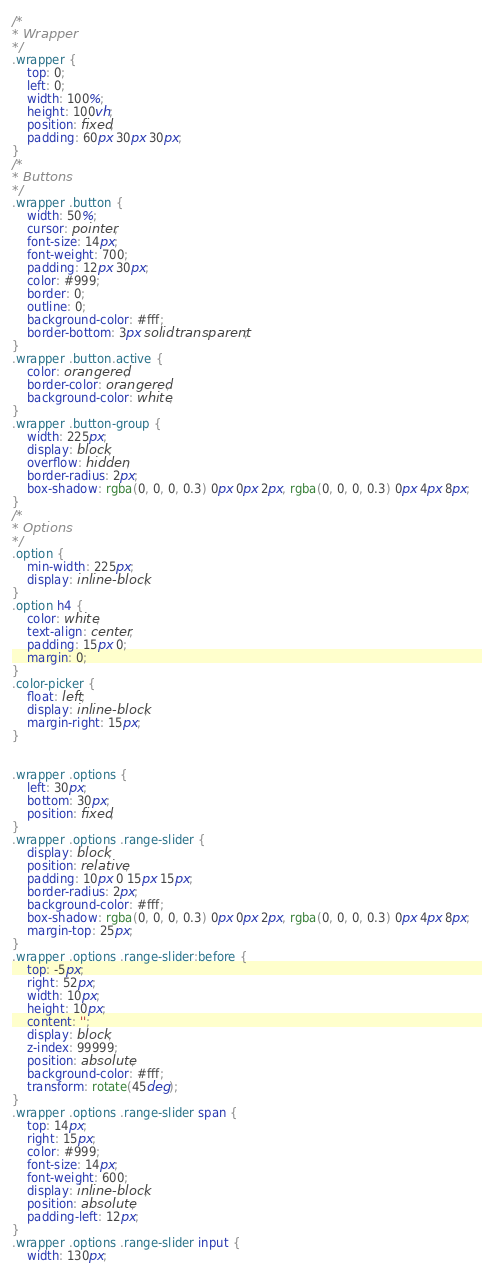Convert code to text. <code><loc_0><loc_0><loc_500><loc_500><_CSS_>/* 
* Wrapper
*/
.wrapper {
    top: 0;
    left: 0;
    width: 100%;
    height: 100vh;
    position: fixed;
    padding: 60px 30px 30px;
}
/* 
* Buttons
*/
.wrapper .button {
    width: 50%;
    cursor: pointer;
    font-size: 14px;
    font-weight: 700;
    padding: 12px 30px;
    color: #999;
    border: 0;
    outline: 0;
    background-color: #fff;
    border-bottom: 3px solid transparent;
}
.wrapper .button.active {
    color: orangered;
    border-color: orangered;
    background-color: white;
}
.wrapper .button-group {
    width: 225px;
    display: block;
    overflow: hidden;
    border-radius: 2px;
    box-shadow: rgba(0, 0, 0, 0.3) 0px 0px 2px, rgba(0, 0, 0, 0.3) 0px 4px 8px;
}
/* 
* Options
*/
.option {
    min-width: 225px;
    display: inline-block;
}
.option h4 {
    color: white;
    text-align: center;
    padding: 15px 0;
    margin: 0;
}
.color-picker {
    float: left;
    display: inline-block;
    margin-right: 15px;
}


.wrapper .options {
    left: 30px;
    bottom: 30px;
    position: fixed;
}
.wrapper .options .range-slider {
    display: block;
    position: relative;
    padding: 10px 0 15px 15px;
    border-radius: 2px;
    background-color: #fff;
    box-shadow: rgba(0, 0, 0, 0.3) 0px 0px 2px, rgba(0, 0, 0, 0.3) 0px 4px 8px;
    margin-top: 25px;
}
.wrapper .options .range-slider:before {
    top: -5px;
    right: 52px;
    width: 10px;
    height: 10px;
    content: '';
    display: block;
    z-index: 99999;
    position: absolute;
    background-color: #fff;
    transform: rotate(45deg);
}
.wrapper .options .range-slider span {
    top: 14px;
    right: 15px;
    color: #999;
    font-size: 14px;
    font-weight: 600;
    display: inline-block;
    position: absolute;
    padding-left: 12px;
}
.wrapper .options .range-slider input {
    width: 130px;</code> 